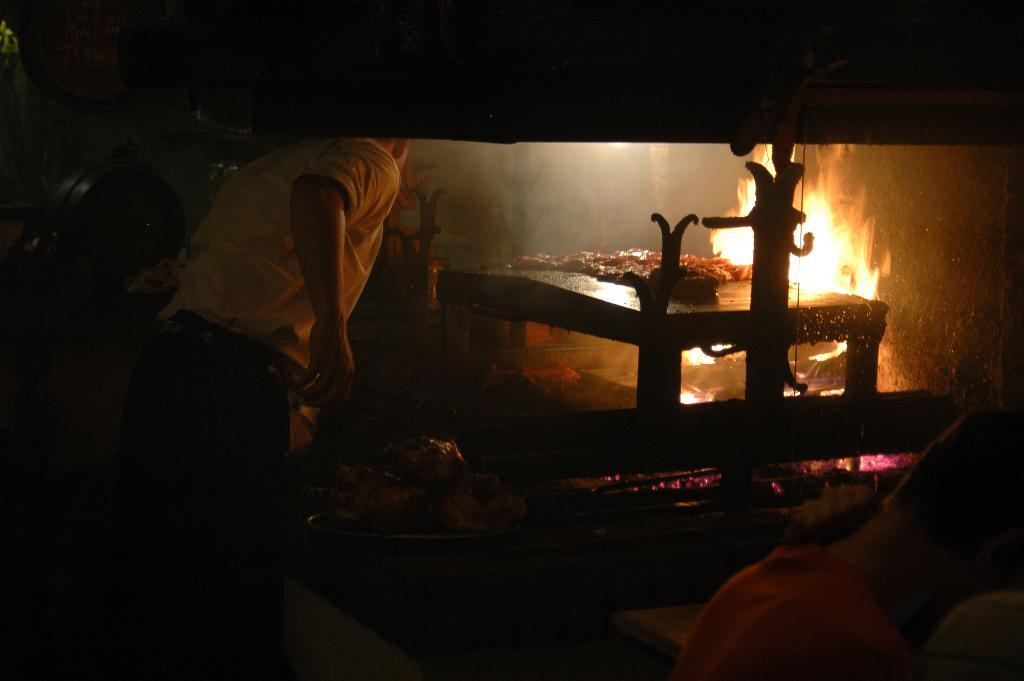What is the main object in the image? There is a table in the image. What can be seen on or near the table? Fire is visible in the image. Where is the person located in the image? The person is standing on the left side of the image. How would you describe the overall lighting in the image? The background of the image is dark. What type of vegetable is being ordered by the person in the image? There is no indication of any vegetable or ordering in the image. Can you tell me how many toes the person in the image has? The image does not show the person's feet or toes, so it cannot be determined from the image. 